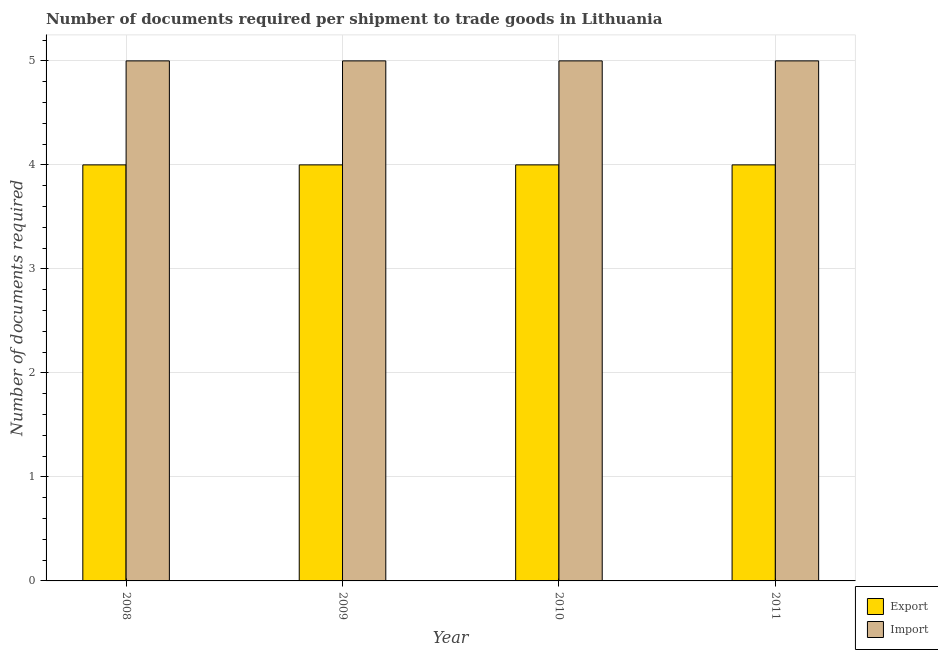How many bars are there on the 3rd tick from the left?
Your answer should be very brief. 2. What is the label of the 1st group of bars from the left?
Ensure brevity in your answer.  2008. In how many cases, is the number of bars for a given year not equal to the number of legend labels?
Provide a succinct answer. 0. What is the number of documents required to import goods in 2011?
Keep it short and to the point. 5. Across all years, what is the maximum number of documents required to export goods?
Give a very brief answer. 4. Across all years, what is the minimum number of documents required to import goods?
Make the answer very short. 5. In which year was the number of documents required to import goods minimum?
Make the answer very short. 2008. What is the total number of documents required to export goods in the graph?
Provide a short and direct response. 16. In the year 2010, what is the difference between the number of documents required to export goods and number of documents required to import goods?
Keep it short and to the point. 0. In how many years, is the number of documents required to import goods greater than 3.8?
Offer a very short reply. 4. Is the number of documents required to import goods in 2008 less than that in 2011?
Keep it short and to the point. No. Is the difference between the number of documents required to export goods in 2009 and 2010 greater than the difference between the number of documents required to import goods in 2009 and 2010?
Give a very brief answer. No. In how many years, is the number of documents required to export goods greater than the average number of documents required to export goods taken over all years?
Provide a succinct answer. 0. What does the 1st bar from the left in 2008 represents?
Offer a very short reply. Export. What does the 2nd bar from the right in 2010 represents?
Provide a succinct answer. Export. How many bars are there?
Offer a very short reply. 8. Are all the bars in the graph horizontal?
Offer a terse response. No. Are the values on the major ticks of Y-axis written in scientific E-notation?
Make the answer very short. No. How many legend labels are there?
Provide a succinct answer. 2. How are the legend labels stacked?
Ensure brevity in your answer.  Vertical. What is the title of the graph?
Offer a terse response. Number of documents required per shipment to trade goods in Lithuania. Does "Primary education" appear as one of the legend labels in the graph?
Offer a very short reply. No. What is the label or title of the Y-axis?
Your answer should be very brief. Number of documents required. What is the Number of documents required of Import in 2008?
Offer a terse response. 5. What is the Number of documents required of Import in 2011?
Your answer should be compact. 5. Across all years, what is the maximum Number of documents required of Import?
Your response must be concise. 5. What is the total Number of documents required in Import in the graph?
Offer a terse response. 20. What is the difference between the Number of documents required of Export in 2008 and that in 2009?
Provide a succinct answer. 0. What is the difference between the Number of documents required of Export in 2008 and that in 2010?
Make the answer very short. 0. What is the difference between the Number of documents required of Import in 2008 and that in 2010?
Make the answer very short. 0. What is the difference between the Number of documents required of Export in 2008 and that in 2011?
Your response must be concise. 0. What is the difference between the Number of documents required in Import in 2008 and that in 2011?
Ensure brevity in your answer.  0. What is the difference between the Number of documents required in Import in 2009 and that in 2010?
Your answer should be compact. 0. What is the difference between the Number of documents required of Export in 2008 and the Number of documents required of Import in 2009?
Make the answer very short. -1. What is the difference between the Number of documents required in Export in 2008 and the Number of documents required in Import in 2010?
Ensure brevity in your answer.  -1. What is the difference between the Number of documents required of Export in 2008 and the Number of documents required of Import in 2011?
Give a very brief answer. -1. What is the difference between the Number of documents required of Export in 2009 and the Number of documents required of Import in 2010?
Keep it short and to the point. -1. What is the average Number of documents required in Export per year?
Your answer should be very brief. 4. What is the average Number of documents required of Import per year?
Offer a terse response. 5. In the year 2011, what is the difference between the Number of documents required in Export and Number of documents required in Import?
Give a very brief answer. -1. What is the ratio of the Number of documents required of Import in 2008 to that in 2009?
Your response must be concise. 1. What is the ratio of the Number of documents required of Export in 2008 to that in 2010?
Keep it short and to the point. 1. What is the ratio of the Number of documents required in Export in 2008 to that in 2011?
Keep it short and to the point. 1. What is the ratio of the Number of documents required of Export in 2009 to that in 2010?
Keep it short and to the point. 1. What is the ratio of the Number of documents required of Import in 2009 to that in 2011?
Your answer should be compact. 1. What is the difference between the highest and the second highest Number of documents required of Export?
Your answer should be compact. 0. What is the difference between the highest and the lowest Number of documents required in Import?
Keep it short and to the point. 0. 